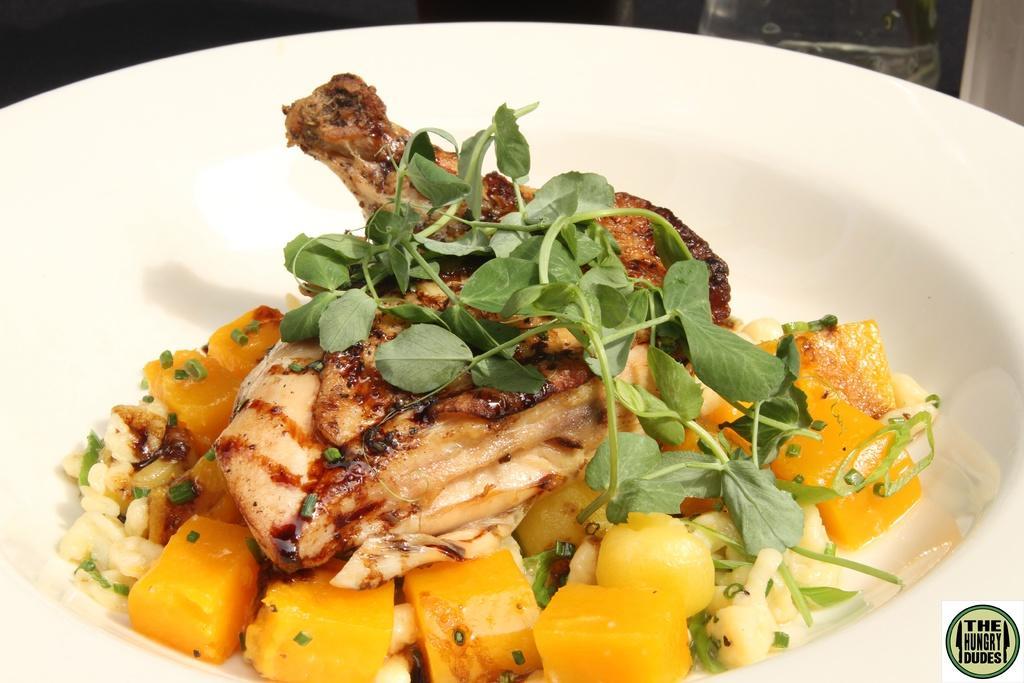Can you describe this image briefly? In this image I can see food which is in yellow, brown, green and cream color. The food is in the bowl and the bowl is in white color. 